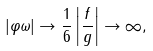Convert formula to latex. <formula><loc_0><loc_0><loc_500><loc_500>| \varphi \omega | \rightarrow \frac { 1 } { 6 } \left | \frac { f } { g } \right | \rightarrow \infty ,</formula> 